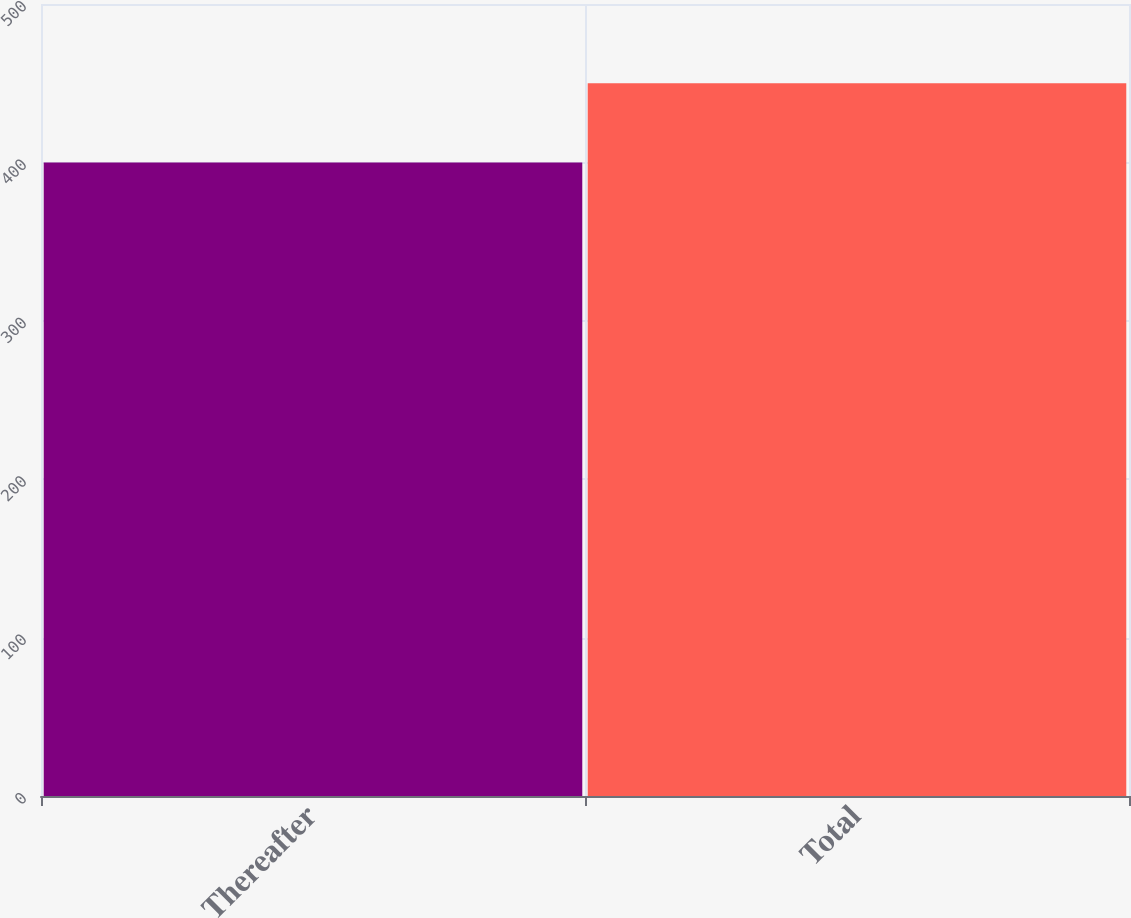Convert chart. <chart><loc_0><loc_0><loc_500><loc_500><bar_chart><fcel>Thereafter<fcel>Total<nl><fcel>400<fcel>450<nl></chart> 